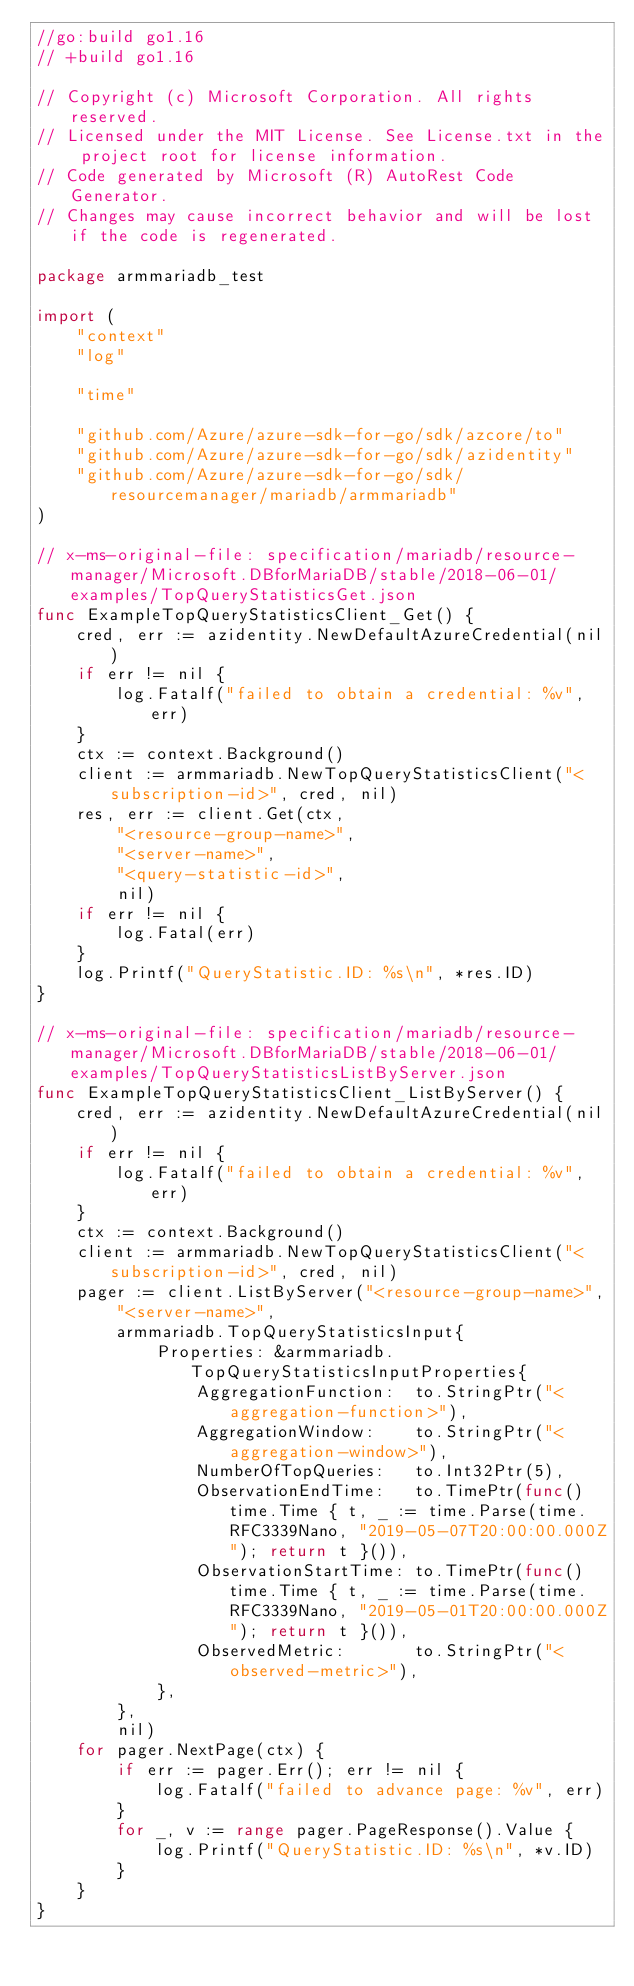<code> <loc_0><loc_0><loc_500><loc_500><_Go_>//go:build go1.16
// +build go1.16

// Copyright (c) Microsoft Corporation. All rights reserved.
// Licensed under the MIT License. See License.txt in the project root for license information.
// Code generated by Microsoft (R) AutoRest Code Generator.
// Changes may cause incorrect behavior and will be lost if the code is regenerated.

package armmariadb_test

import (
	"context"
	"log"

	"time"

	"github.com/Azure/azure-sdk-for-go/sdk/azcore/to"
	"github.com/Azure/azure-sdk-for-go/sdk/azidentity"
	"github.com/Azure/azure-sdk-for-go/sdk/resourcemanager/mariadb/armmariadb"
)

// x-ms-original-file: specification/mariadb/resource-manager/Microsoft.DBforMariaDB/stable/2018-06-01/examples/TopQueryStatisticsGet.json
func ExampleTopQueryStatisticsClient_Get() {
	cred, err := azidentity.NewDefaultAzureCredential(nil)
	if err != nil {
		log.Fatalf("failed to obtain a credential: %v", err)
	}
	ctx := context.Background()
	client := armmariadb.NewTopQueryStatisticsClient("<subscription-id>", cred, nil)
	res, err := client.Get(ctx,
		"<resource-group-name>",
		"<server-name>",
		"<query-statistic-id>",
		nil)
	if err != nil {
		log.Fatal(err)
	}
	log.Printf("QueryStatistic.ID: %s\n", *res.ID)
}

// x-ms-original-file: specification/mariadb/resource-manager/Microsoft.DBforMariaDB/stable/2018-06-01/examples/TopQueryStatisticsListByServer.json
func ExampleTopQueryStatisticsClient_ListByServer() {
	cred, err := azidentity.NewDefaultAzureCredential(nil)
	if err != nil {
		log.Fatalf("failed to obtain a credential: %v", err)
	}
	ctx := context.Background()
	client := armmariadb.NewTopQueryStatisticsClient("<subscription-id>", cred, nil)
	pager := client.ListByServer("<resource-group-name>",
		"<server-name>",
		armmariadb.TopQueryStatisticsInput{
			Properties: &armmariadb.TopQueryStatisticsInputProperties{
				AggregationFunction:  to.StringPtr("<aggregation-function>"),
				AggregationWindow:    to.StringPtr("<aggregation-window>"),
				NumberOfTopQueries:   to.Int32Ptr(5),
				ObservationEndTime:   to.TimePtr(func() time.Time { t, _ := time.Parse(time.RFC3339Nano, "2019-05-07T20:00:00.000Z"); return t }()),
				ObservationStartTime: to.TimePtr(func() time.Time { t, _ := time.Parse(time.RFC3339Nano, "2019-05-01T20:00:00.000Z"); return t }()),
				ObservedMetric:       to.StringPtr("<observed-metric>"),
			},
		},
		nil)
	for pager.NextPage(ctx) {
		if err := pager.Err(); err != nil {
			log.Fatalf("failed to advance page: %v", err)
		}
		for _, v := range pager.PageResponse().Value {
			log.Printf("QueryStatistic.ID: %s\n", *v.ID)
		}
	}
}
</code> 